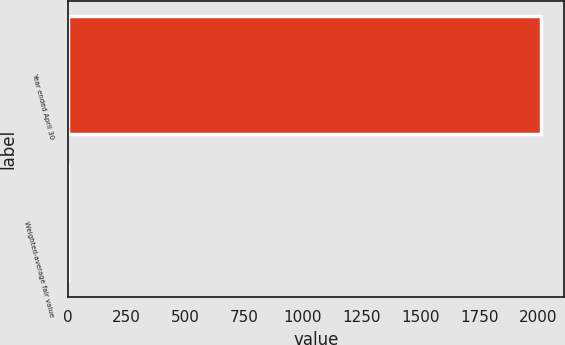<chart> <loc_0><loc_0><loc_500><loc_500><bar_chart><fcel>Year ended April 30<fcel>Weighted-average fair value<nl><fcel>2011<fcel>2.25<nl></chart> 